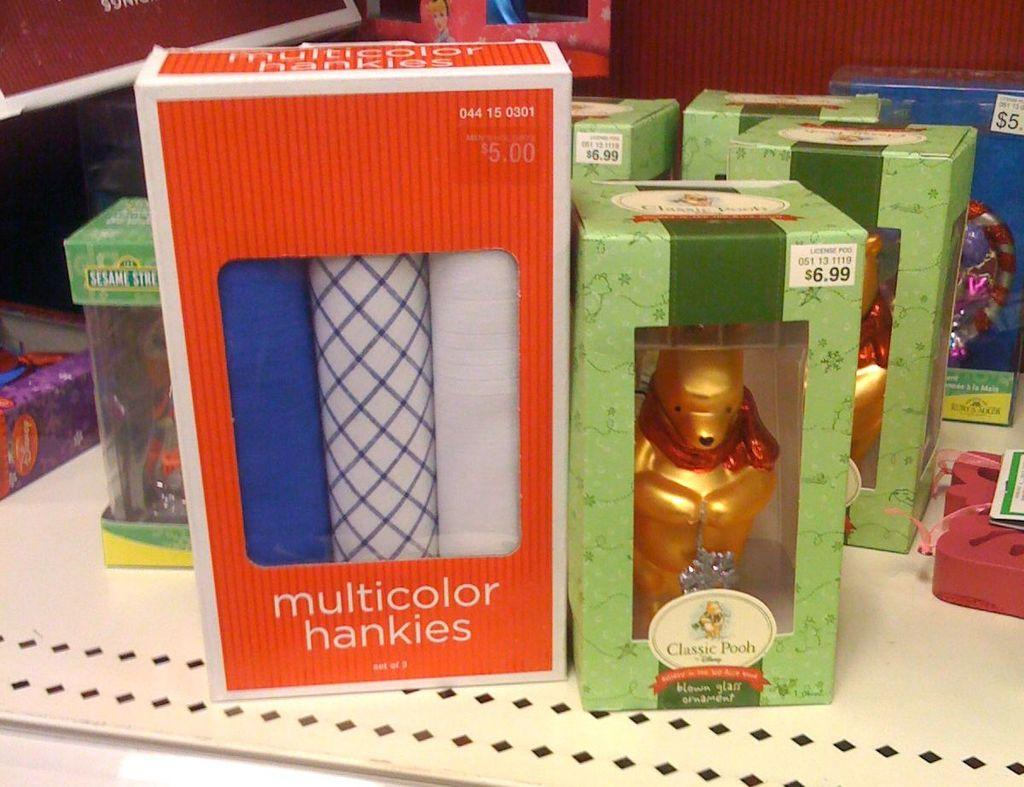What type of objects can be seen in the image? There are toys and cloth items visible in the image. Where are the toys and cloth items placed? They are on boxes in the image. What is the location of the boxes? The boxes are on a table. What can be seen at the top of the image? There is a red color fence visible at the top of the image. How does the faucet trick the hope in the image? There is no faucet or hope present in the image; it only features toys, cloth items, boxes, a table, and a red color fence. 